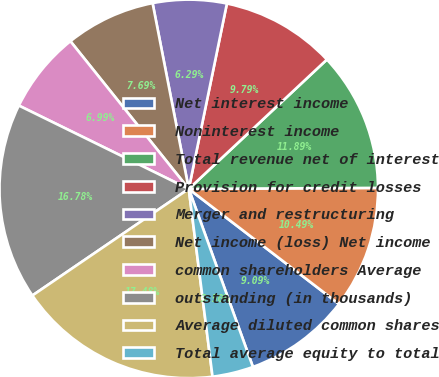Convert chart. <chart><loc_0><loc_0><loc_500><loc_500><pie_chart><fcel>Net interest income<fcel>Noninterest income<fcel>Total revenue net of interest<fcel>Provision for credit losses<fcel>Merger and restructuring<fcel>Net income (loss) Net income<fcel>common shareholders Average<fcel>outstanding (in thousands)<fcel>Average diluted common shares<fcel>Total average equity to total<nl><fcel>9.09%<fcel>10.49%<fcel>11.89%<fcel>9.79%<fcel>6.29%<fcel>7.69%<fcel>6.99%<fcel>16.78%<fcel>17.48%<fcel>3.5%<nl></chart> 